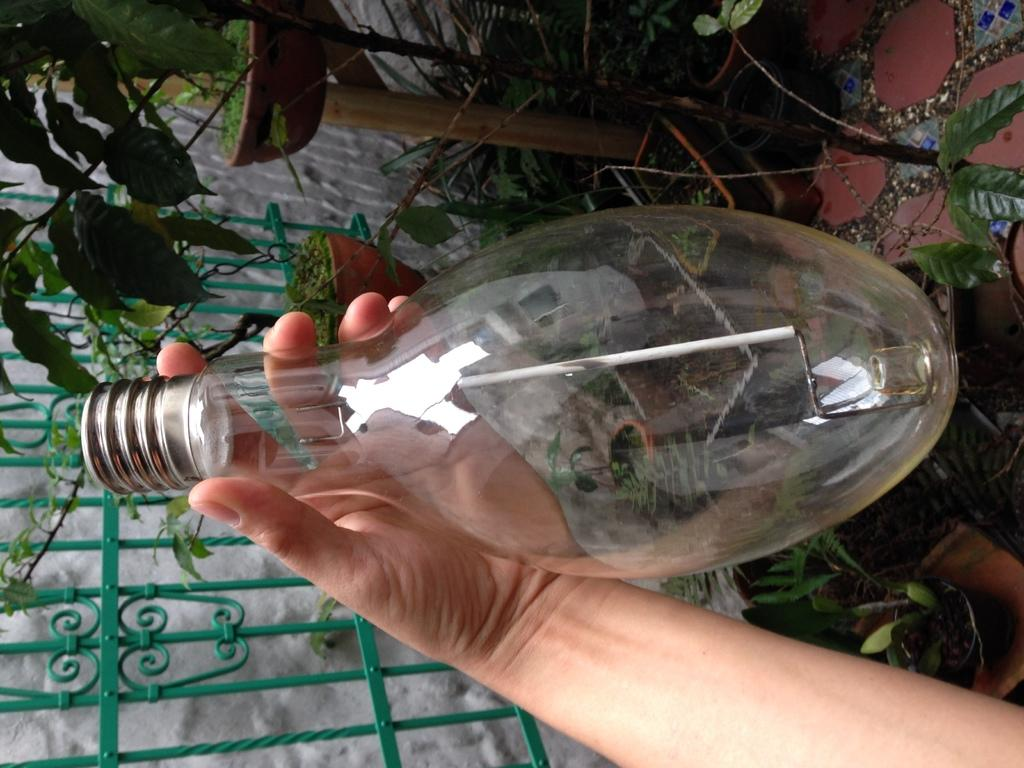What is the person in the image holding? The person is holding a bulb in the image. What can be seen in the background of the image? There are metal rods, flower pots, and plants in the background of the image. What type of ink can be seen on the side of the sheep in the image? There are no sheep present in the image, so there is no ink or any other substance on their side. 